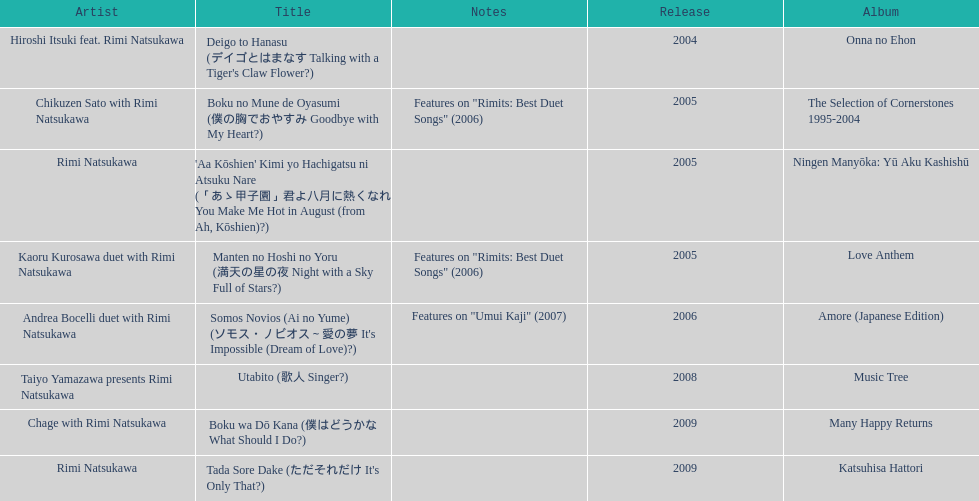Give me the full table as a dictionary. {'header': ['Artist', 'Title', 'Notes', 'Release', 'Album'], 'rows': [['Hiroshi Itsuki feat. Rimi Natsukawa', "Deigo to Hanasu (デイゴとはまなす Talking with a Tiger's Claw Flower?)", '', '2004', 'Onna no Ehon'], ['Chikuzen Sato with Rimi Natsukawa', 'Boku no Mune de Oyasumi (僕の胸でおやすみ Goodbye with My Heart?)', 'Features on "Rimits: Best Duet Songs" (2006)', '2005', 'The Selection of Cornerstones 1995-2004'], ['Rimi Natsukawa', "'Aa Kōshien' Kimi yo Hachigatsu ni Atsuku Nare (「あゝ甲子園」君よ八月に熱くなれ You Make Me Hot in August (from Ah, Kōshien)?)", '', '2005', 'Ningen Manyōka: Yū Aku Kashishū'], ['Kaoru Kurosawa duet with Rimi Natsukawa', 'Manten no Hoshi no Yoru (満天の星の夜 Night with a Sky Full of Stars?)', 'Features on "Rimits: Best Duet Songs" (2006)', '2005', 'Love Anthem'], ['Andrea Bocelli duet with Rimi Natsukawa', "Somos Novios (Ai no Yume) (ソモス・ノビオス～愛の夢 It's Impossible (Dream of Love)?)", 'Features on "Umui Kaji" (2007)', '2006', 'Amore (Japanese Edition)'], ['Taiyo Yamazawa presents Rimi Natsukawa', 'Utabito (歌人 Singer?)', '', '2008', 'Music Tree'], ['Chage with Rimi Natsukawa', 'Boku wa Dō Kana (僕はどうかな What Should I Do?)', '', '2009', 'Many Happy Returns'], ['Rimi Natsukawa', "Tada Sore Dake (ただそれだけ It's Only That?)", '', '2009', 'Katsuhisa Hattori']]} What song was this artist on after utabito? Boku wa Dō Kana. 